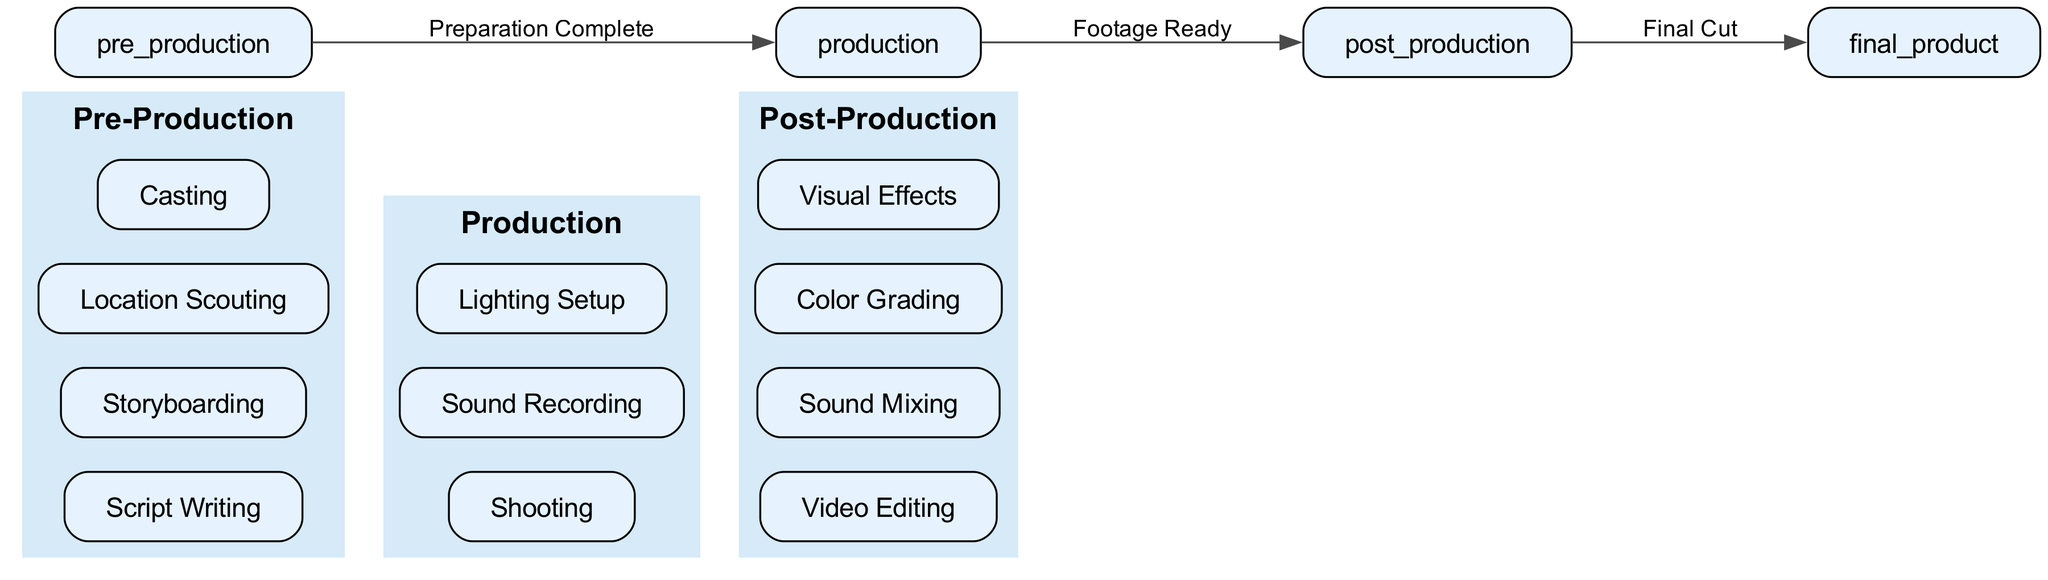What are the three main stages of the video production workflow? The diagram clearly labels three primary stages: Pre-Production, Production, and Post-Production, which are visually distinct and organized in a left-to-right flow.
Answer: Pre-Production, Production, Post-Production How many tasks are listed under Production? In the production section of the diagram, there are three tasks named Shooting, Sound Recording, and Lighting Setup. Counting these reveals a total of three tasks.
Answer: Three What is the first task listed in Post-Production? The diagram indicates that the first task under the Post-Production section is Video Editing, as it is the first child node listed under that main stage.
Answer: Video Editing What connects Pre-Production to Production? The diagram shows an edge labeled "Preparation Complete" linking Pre-Production and Production, indicating the relationship or workflow transition between these two stages.
Answer: Preparation Complete How many edges are there connecting the three stages? By observing the diagram, we see there are three edges: one from Pre-Production to Production, one from Production to Post-Production, and another leading to the final product from Post-Production. Thus, the total is three edges.
Answer: Three What task comes after Shooting in the workflow? The diagram's flow shows that after Shooting, the next task is Sound Recording, as that task is directly connected to Shooting in the Production phase.
Answer: Sound Recording What completes the workflow from Post-Production? According to the diagram, the completion of the workflow from Post-Production is represented by the edge labeled "Final Cut," indicating the transition to the final product stage.
Answer: Final Cut How many tasks are there in Pre-Production? In reviewing the Pre-Production section, we find four tasks listed: Script Writing, Storyboarding, Location Scouting, and Casting, resulting in a total of four tasks.
Answer: Four 